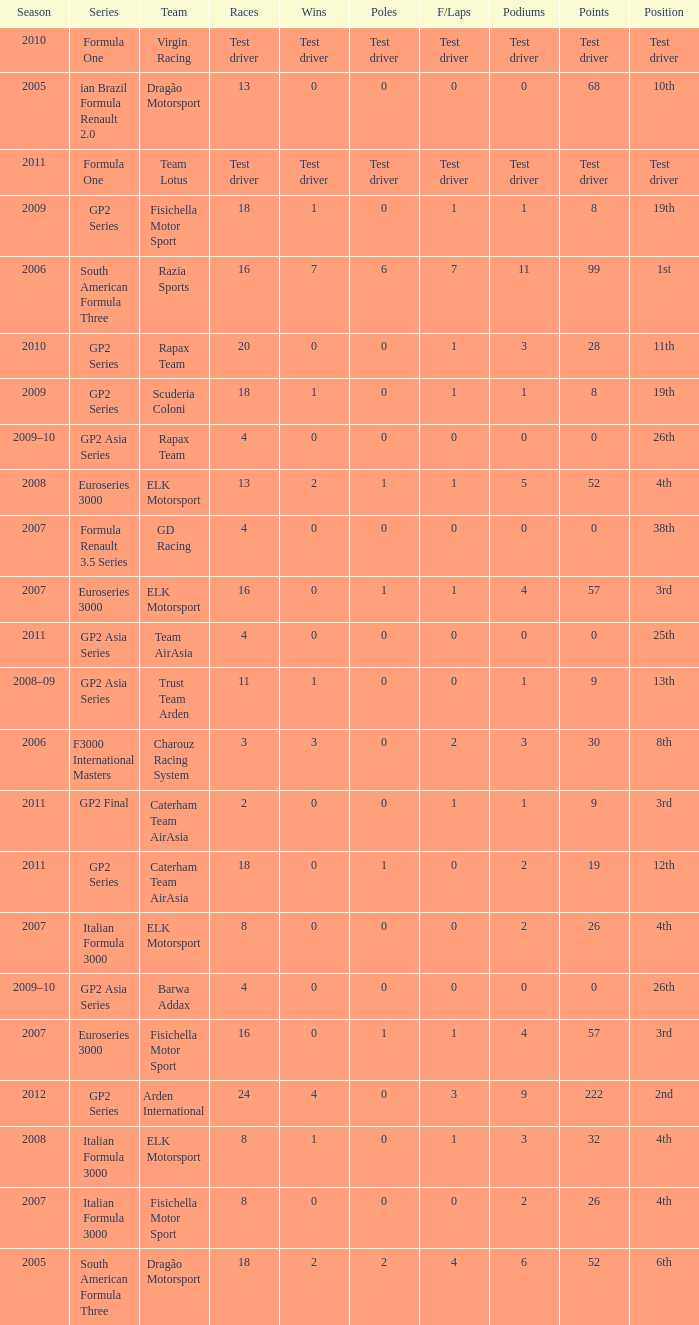What was his position in 2009 with 1 win? 19th, 19th. 